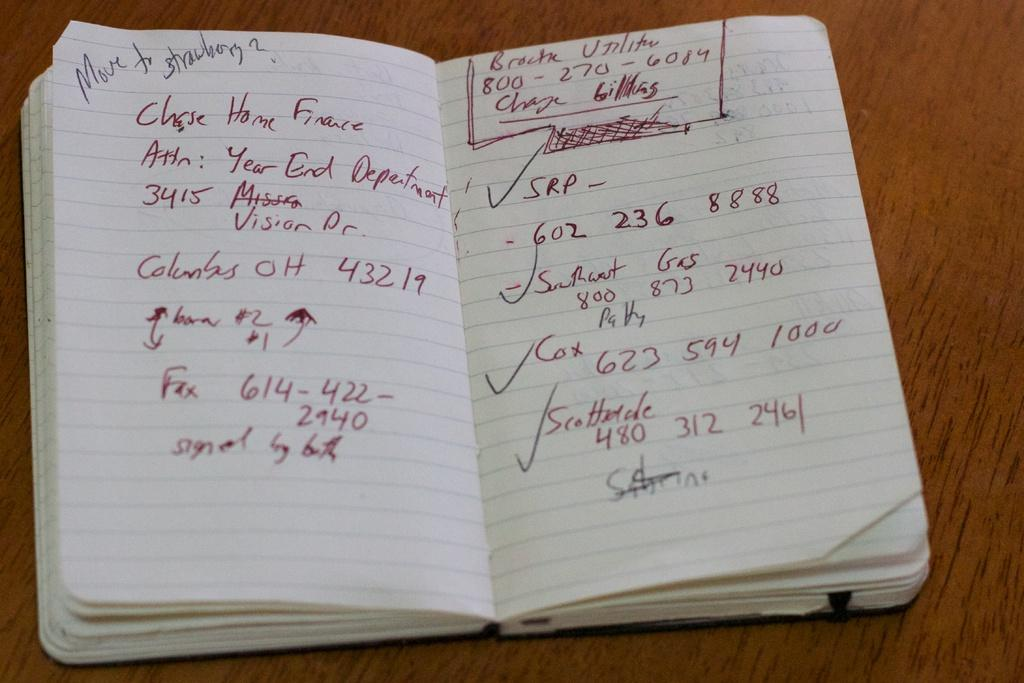What object is present in the image that is typically used for reading and learning? There is a book in the image. What can be seen on the book? There is writing on the book. What is the color of the surface on which the book is placed? The book is on a brown color surface. What type of rifle is your uncle holding in the image? There is no rifle or uncle present in the image; it only features a book with writing on it. How does the book shake in the image? The book does not shake in the image; it is stationary on the brown color surface. 